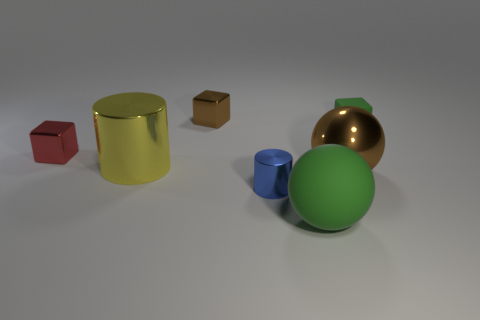Add 3 yellow metallic cylinders. How many objects exist? 10 Subtract all brown metal blocks. How many blocks are left? 2 Subtract all green cubes. How many cubes are left? 2 Subtract all spheres. How many objects are left? 5 Add 1 yellow things. How many yellow things are left? 2 Add 4 yellow balls. How many yellow balls exist? 4 Subtract 0 brown cylinders. How many objects are left? 7 Subtract 1 balls. How many balls are left? 1 Subtract all blue cubes. Subtract all yellow spheres. How many cubes are left? 3 Subtract all cyan blocks. How many blue cylinders are left? 1 